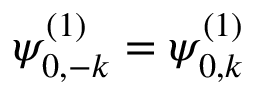<formula> <loc_0><loc_0><loc_500><loc_500>\psi _ { 0 , - k } ^ { ( 1 ) } = \psi _ { 0 , k } ^ { ( 1 ) }</formula> 